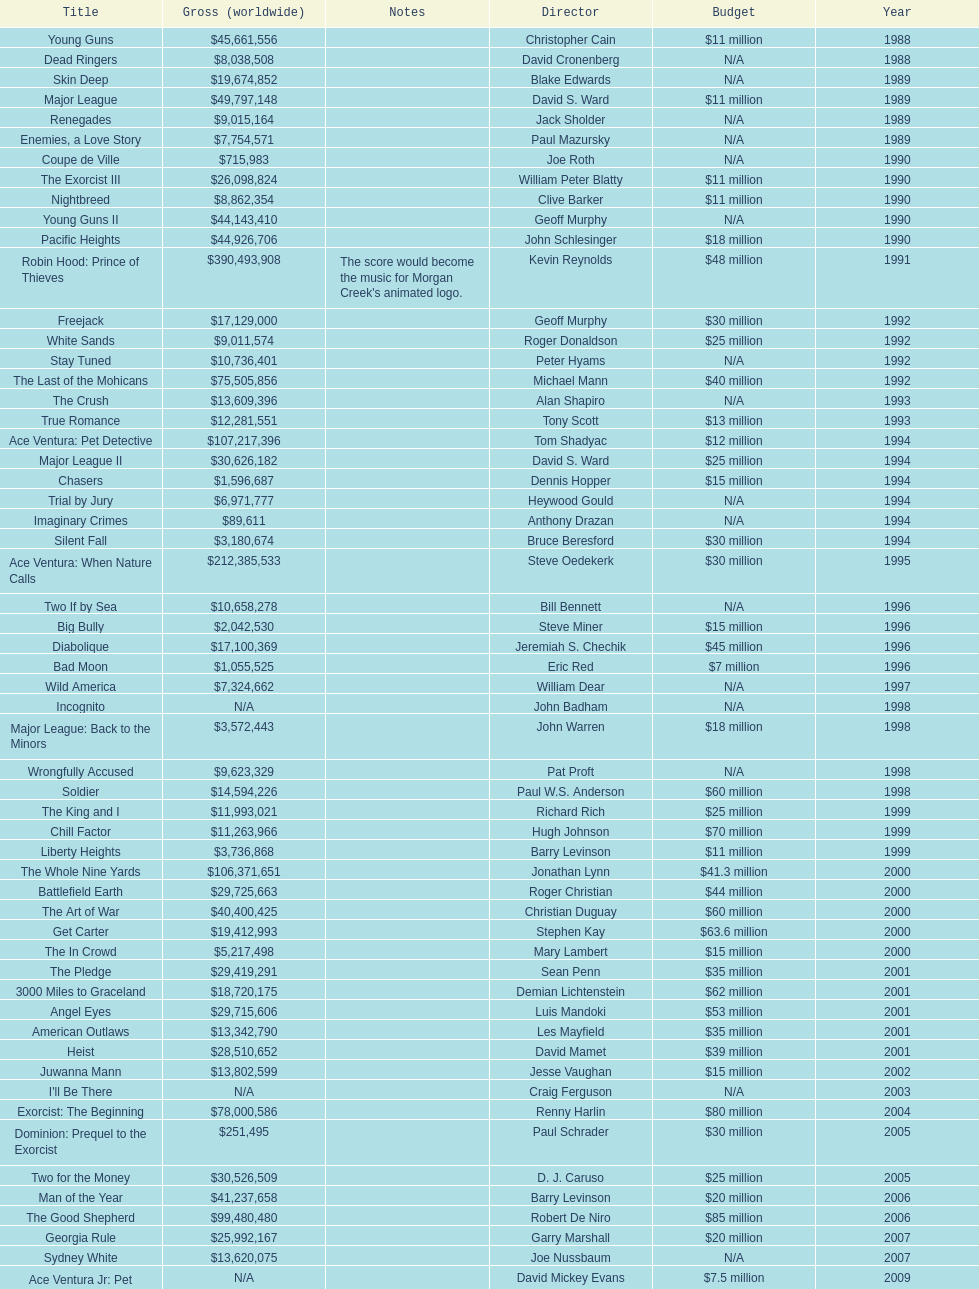How many films did morgan creek make in 2006? 2. 